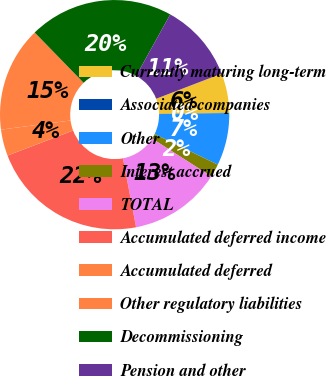Convert chart to OTSL. <chart><loc_0><loc_0><loc_500><loc_500><pie_chart><fcel>Currently maturing long-term<fcel>Associated companies<fcel>Other<fcel>Interest accrued<fcel>TOTAL<fcel>Accumulated deferred income<fcel>Accumulated deferred<fcel>Other regulatory liabilities<fcel>Decommissioning<fcel>Pension and other<nl><fcel>5.57%<fcel>0.03%<fcel>7.41%<fcel>1.87%<fcel>12.95%<fcel>22.19%<fcel>3.72%<fcel>14.8%<fcel>20.34%<fcel>11.11%<nl></chart> 